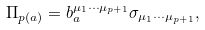Convert formula to latex. <formula><loc_0><loc_0><loc_500><loc_500>\Pi _ { p ( a ) } = b _ { a } ^ { \mu _ { 1 } \cdots \mu _ { p + 1 } } \sigma _ { \mu _ { 1 } \cdots \mu _ { p + 1 } } ,</formula> 